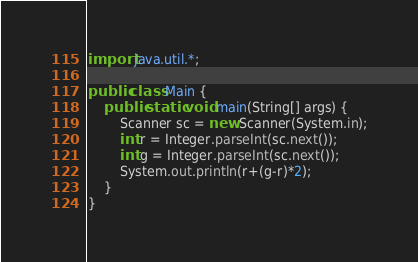Convert code to text. <code><loc_0><loc_0><loc_500><loc_500><_Java_>import java.util.*;
 
public class Main {
    public static void main(String[] args) {
        Scanner sc = new Scanner(System.in);
        int r = Integer.parseInt(sc.next());
        int g = Integer.parseInt(sc.next());
        System.out.println(r+(g-r)*2);
    }
}</code> 